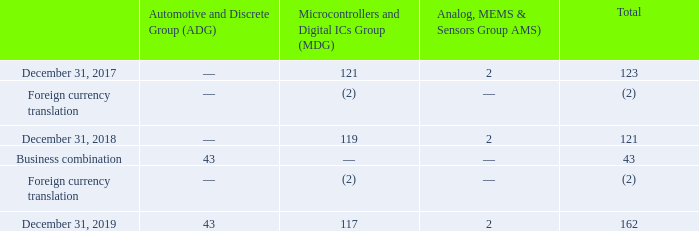As described in Note 7, the acquisition of Norstel resulted in the recognition of $43 million in goodwill which has been included in the ADG segment to align the goodwill of the acquired Company with the segment under which the related activities will be reported.
As of the end of the third quarters of 2019 and 2018, the Company performed its annual impairment test. The Company did not elect to perform a qualitative assessment. The impairment test was conducted following a two-step process. In the first step, the Company compared the fair value of the reporting units tested to their carrying value. Based upon the first step of the goodwill impairment test, no impairment was recorded since the fair value of the reporting units exceeded their carrying value.
Goodwill as at December 31, 2019 and 2018 is net of accumulated impairment losses of $102 million, of which $96 million relates to the MDG segment and $6 million to Others. In 2019, 2018 and 2017, no impairment loss was recorded by the Company.
How many million did the acquisition of Norstel contributed to goodwill? $43 million. What are the steps included in the impairment test? In the first step, the company compared the fair value of the reporting units tested to their carrying value. based upon the first step of the goodwill impairment test, no impairment was recorded since the fair value of the reporting units exceeded their carrying value. How much no impairment loss was recorded by the Company in 2019, 2018 and 2017? In 2019, 2018 and 2017, no impairment loss was recorded by the company. What is the average goodwill for the period December 31, 2017?
Answer scale should be: million. 123 / 2
Answer: 61.5. What is the average goodwill for the period December 31, 2018?
Answer scale should be: million. 121 / 2
Answer: 60.5. What is the average goodwill for the period December 31, 2019?
Answer scale should be: million. 162/ 3
Answer: 54. 